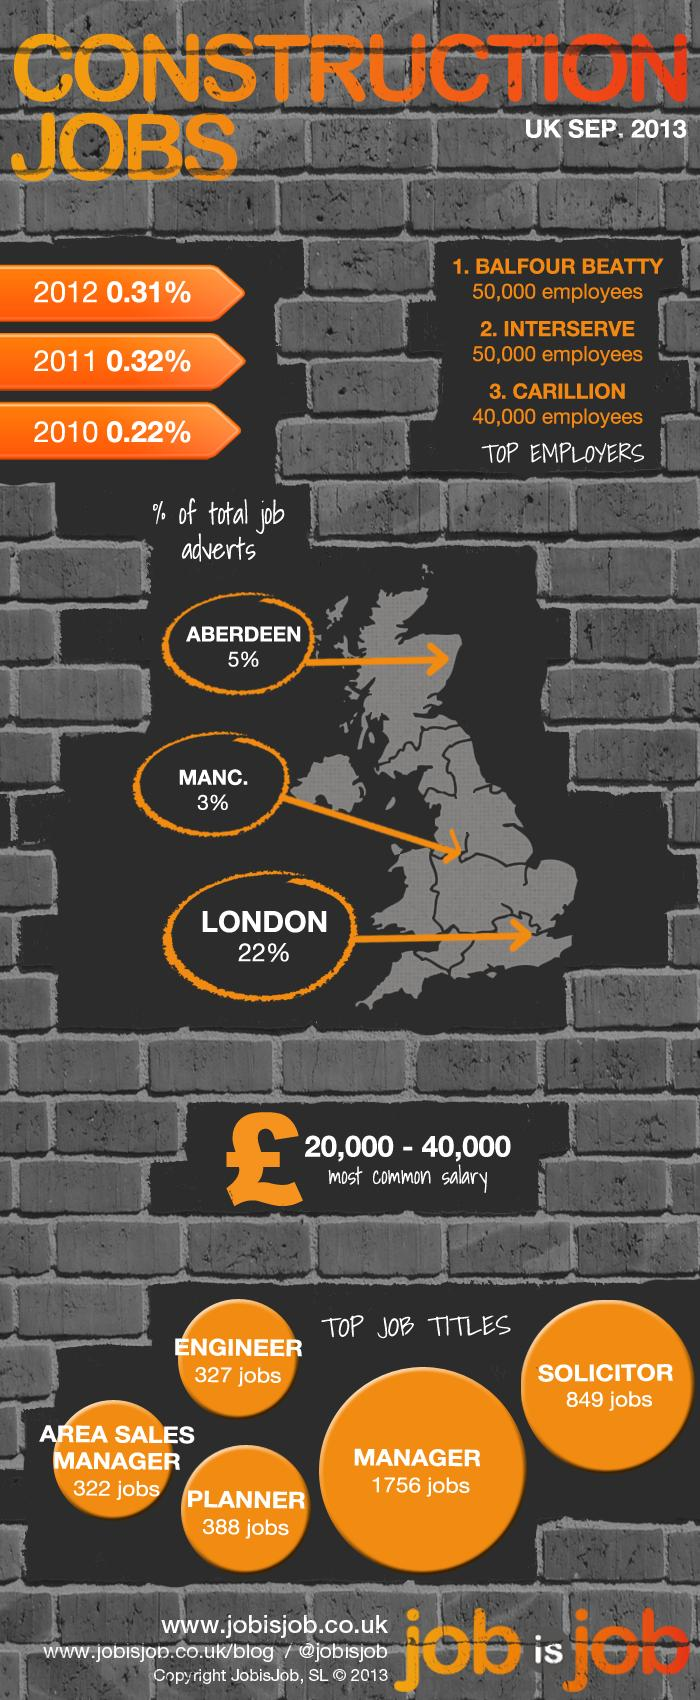Specify some key components in this picture. The percentage of total job advertisements in London is 78%. There are currently 849 job opportunities available in the UK for the job title solicitor. There are currently 1756 job openings for managers in the construction industry in the UK. The top construction companies in the UK are Balfour Beauty, Interserve, and Carillion. Out of the top 3 construction companies, the one with the least number of employees is Carillion. 